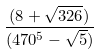Convert formula to latex. <formula><loc_0><loc_0><loc_500><loc_500>\frac { ( 8 + \sqrt { 3 2 6 } ) } { ( 4 7 0 ^ { 5 } - \sqrt { 5 } ) }</formula> 